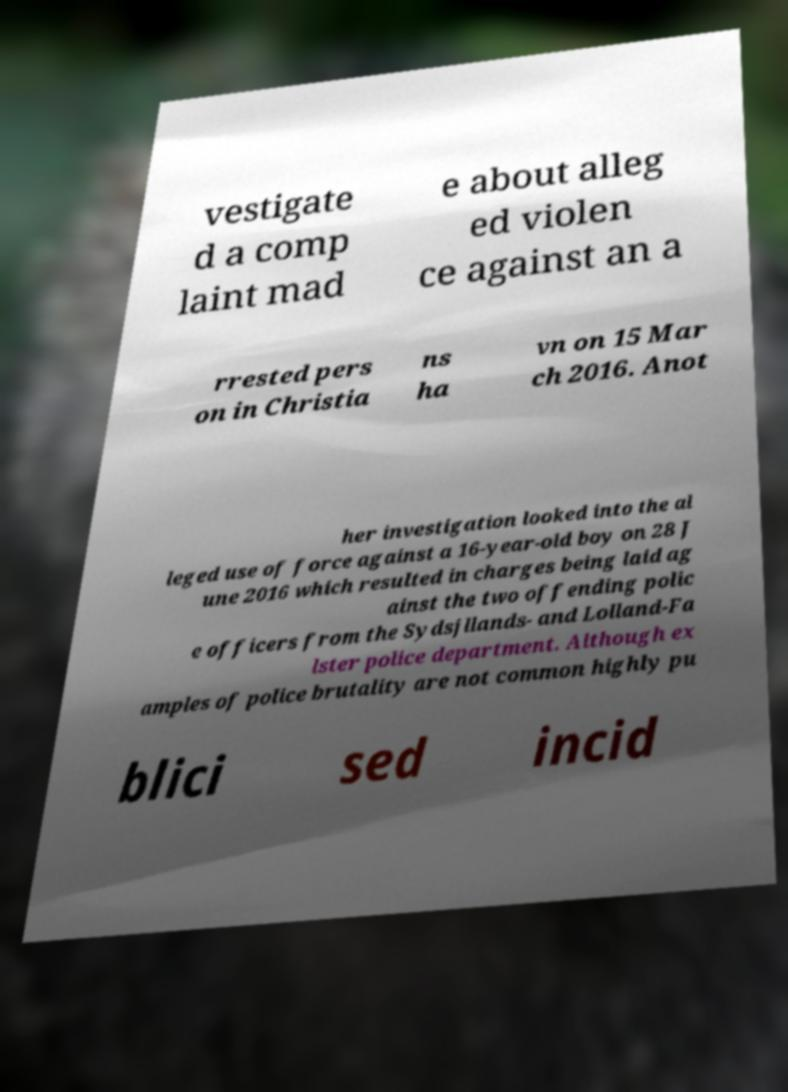For documentation purposes, I need the text within this image transcribed. Could you provide that? vestigate d a comp laint mad e about alleg ed violen ce against an a rrested pers on in Christia ns ha vn on 15 Mar ch 2016. Anot her investigation looked into the al leged use of force against a 16-year-old boy on 28 J une 2016 which resulted in charges being laid ag ainst the two offending polic e officers from the Sydsjllands- and Lolland-Fa lster police department. Although ex amples of police brutality are not common highly pu blici sed incid 